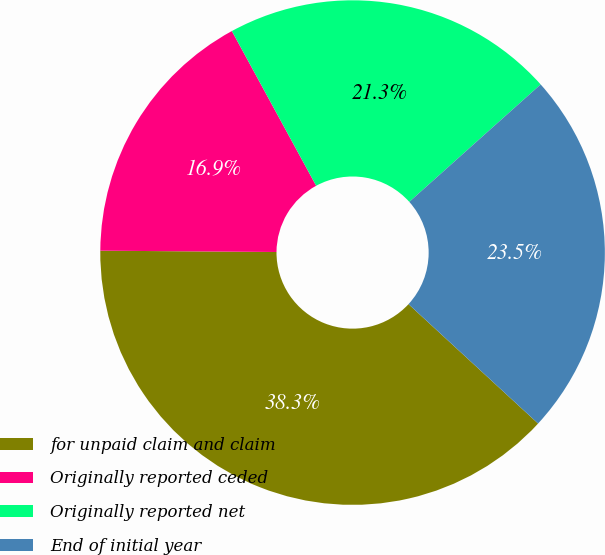Convert chart to OTSL. <chart><loc_0><loc_0><loc_500><loc_500><pie_chart><fcel>for unpaid claim and claim<fcel>Originally reported ceded<fcel>Originally reported net<fcel>End of initial year<nl><fcel>38.27%<fcel>16.94%<fcel>21.33%<fcel>23.46%<nl></chart> 